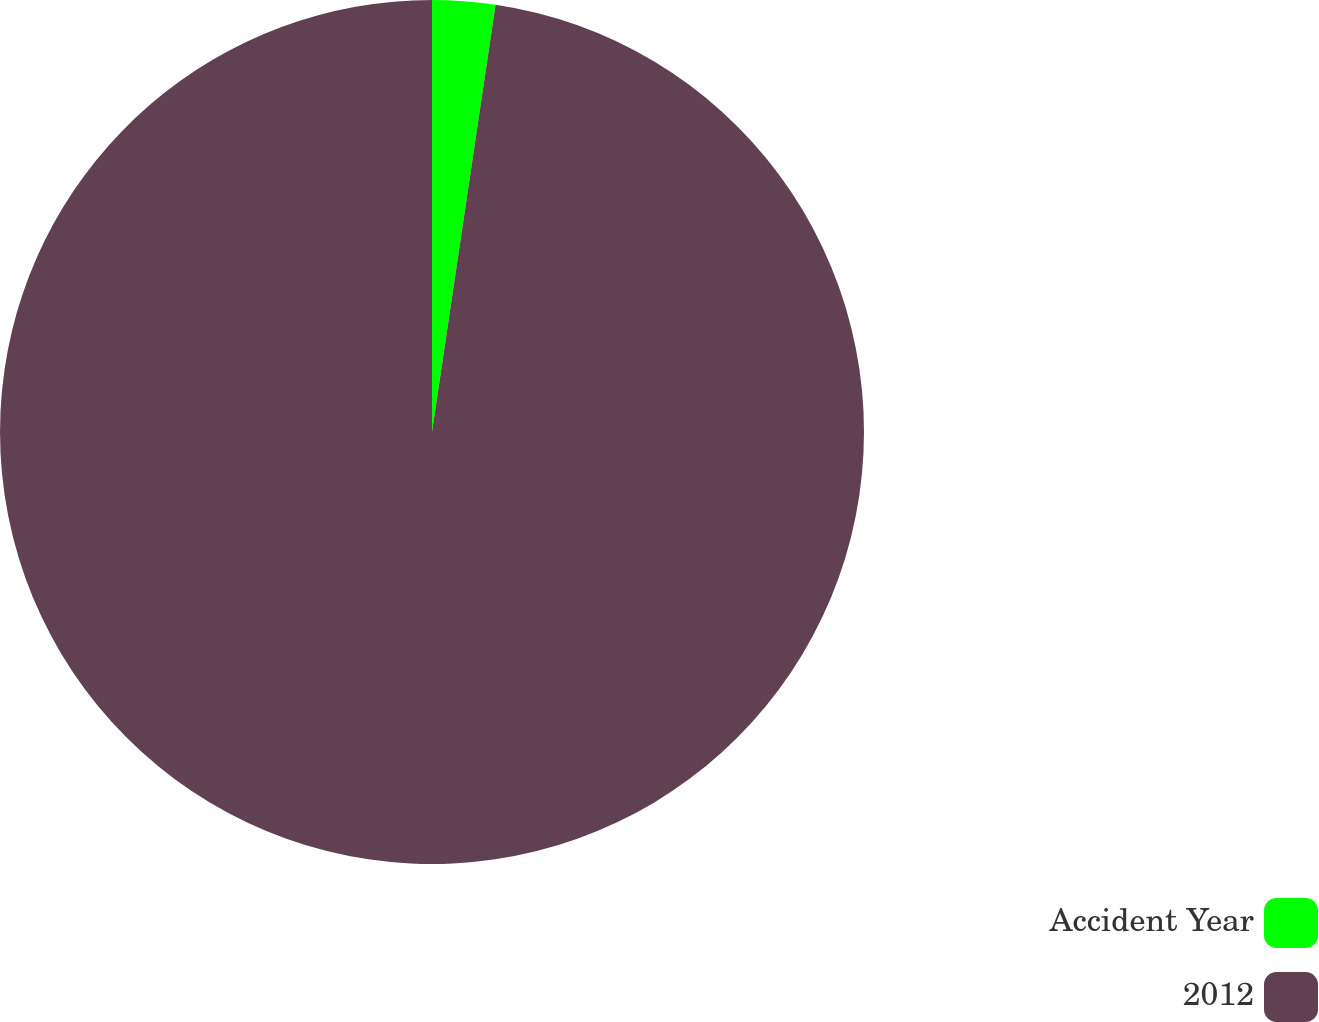Convert chart to OTSL. <chart><loc_0><loc_0><loc_500><loc_500><pie_chart><fcel>Accident Year<fcel>2012<nl><fcel>2.35%<fcel>97.65%<nl></chart> 